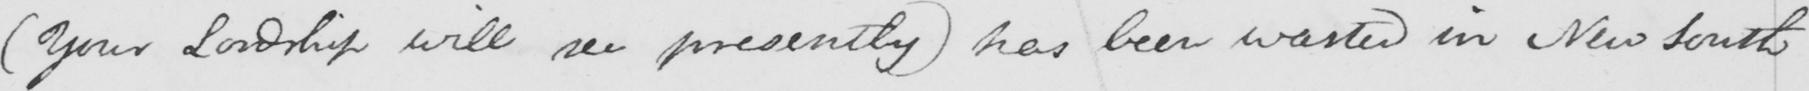Can you read and transcribe this handwriting? ( Your Lordship will see presently )  has been wasted in New South 